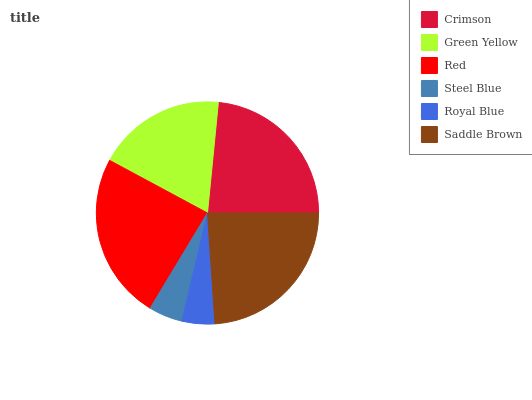Is Royal Blue the minimum?
Answer yes or no. Yes. Is Red the maximum?
Answer yes or no. Yes. Is Green Yellow the minimum?
Answer yes or no. No. Is Green Yellow the maximum?
Answer yes or no. No. Is Crimson greater than Green Yellow?
Answer yes or no. Yes. Is Green Yellow less than Crimson?
Answer yes or no. Yes. Is Green Yellow greater than Crimson?
Answer yes or no. No. Is Crimson less than Green Yellow?
Answer yes or no. No. Is Crimson the high median?
Answer yes or no. Yes. Is Green Yellow the low median?
Answer yes or no. Yes. Is Royal Blue the high median?
Answer yes or no. No. Is Royal Blue the low median?
Answer yes or no. No. 